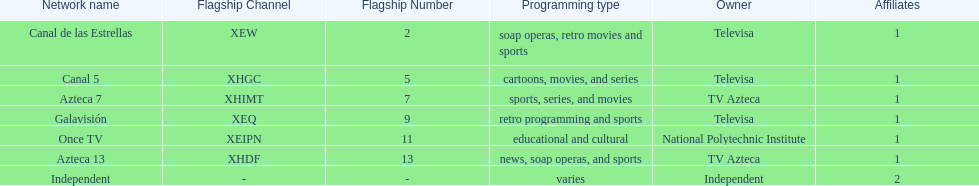What stations show sports? Soap operas, retro movies and sports, retro programming and sports, news, soap operas, and sports. What of these is not affiliated with televisa? Azteca 7. 